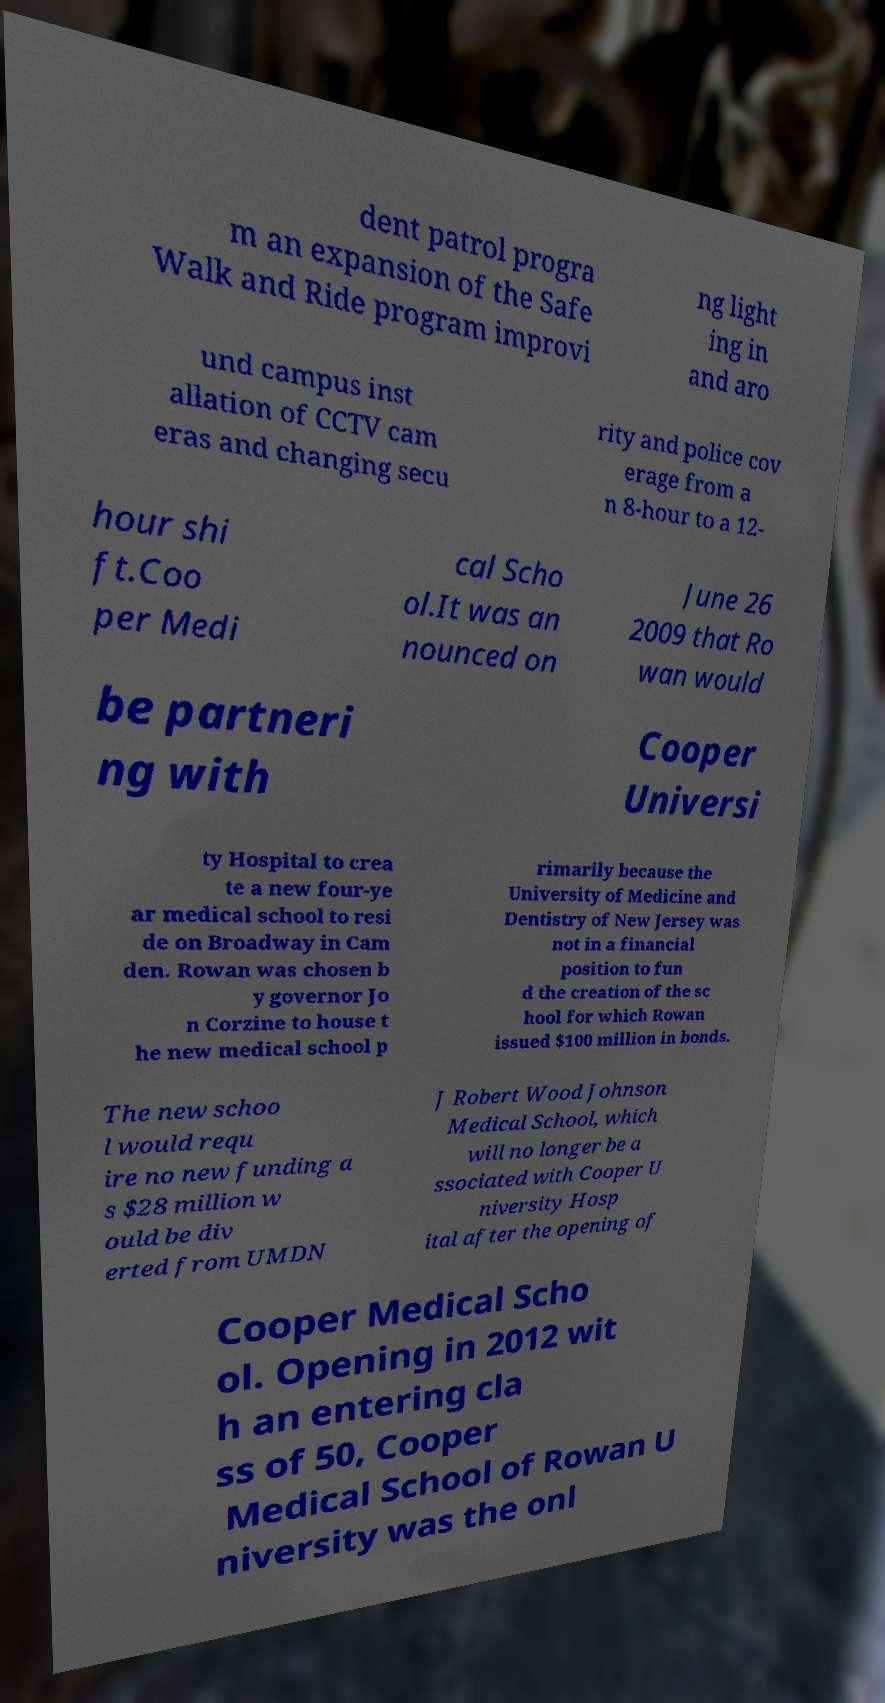What messages or text are displayed in this image? I need them in a readable, typed format. dent patrol progra m an expansion of the Safe Walk and Ride program improvi ng light ing in and aro und campus inst allation of CCTV cam eras and changing secu rity and police cov erage from a n 8-hour to a 12- hour shi ft.Coo per Medi cal Scho ol.It was an nounced on June 26 2009 that Ro wan would be partneri ng with Cooper Universi ty Hospital to crea te a new four-ye ar medical school to resi de on Broadway in Cam den. Rowan was chosen b y governor Jo n Corzine to house t he new medical school p rimarily because the University of Medicine and Dentistry of New Jersey was not in a financial position to fun d the creation of the sc hool for which Rowan issued $100 million in bonds. The new schoo l would requ ire no new funding a s $28 million w ould be div erted from UMDN J Robert Wood Johnson Medical School, which will no longer be a ssociated with Cooper U niversity Hosp ital after the opening of Cooper Medical Scho ol. Opening in 2012 wit h an entering cla ss of 50, Cooper Medical School of Rowan U niversity was the onl 